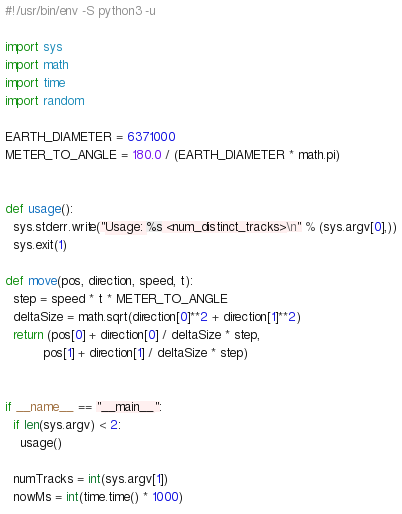<code> <loc_0><loc_0><loc_500><loc_500><_Python_>#!/usr/bin/env -S python3 -u

import sys
import math
import time
import random

EARTH_DIAMETER = 6371000
METER_TO_ANGLE = 180.0 / (EARTH_DIAMETER * math.pi)


def usage():
  sys.stderr.write("Usage: %s <num_distinct_tracks>\n" % (sys.argv[0],))
  sys.exit(1)

def move(pos, direction, speed, t):
  step = speed * t * METER_TO_ANGLE
  deltaSize = math.sqrt(direction[0]**2 + direction[1]**2)
  return (pos[0] + direction[0] / deltaSize * step,
          pos[1] + direction[1] / deltaSize * step)


if __name__ == "__main__":
  if len(sys.argv) < 2:
    usage()

  numTracks = int(sys.argv[1])
  nowMs = int(time.time() * 1000)</code> 